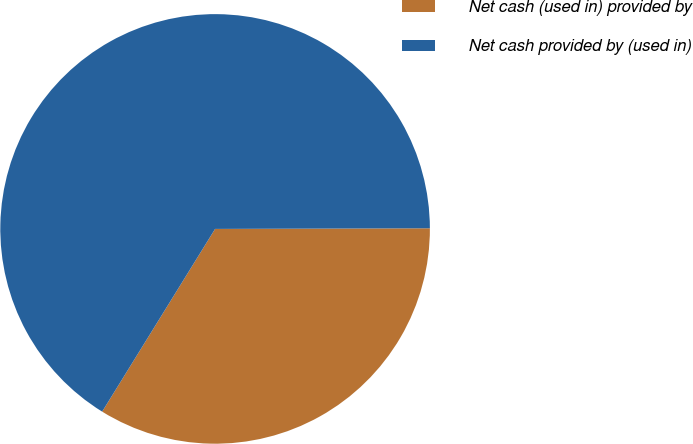Convert chart to OTSL. <chart><loc_0><loc_0><loc_500><loc_500><pie_chart><fcel>Net cash (used in) provided by<fcel>Net cash provided by (used in)<nl><fcel>33.86%<fcel>66.14%<nl></chart> 